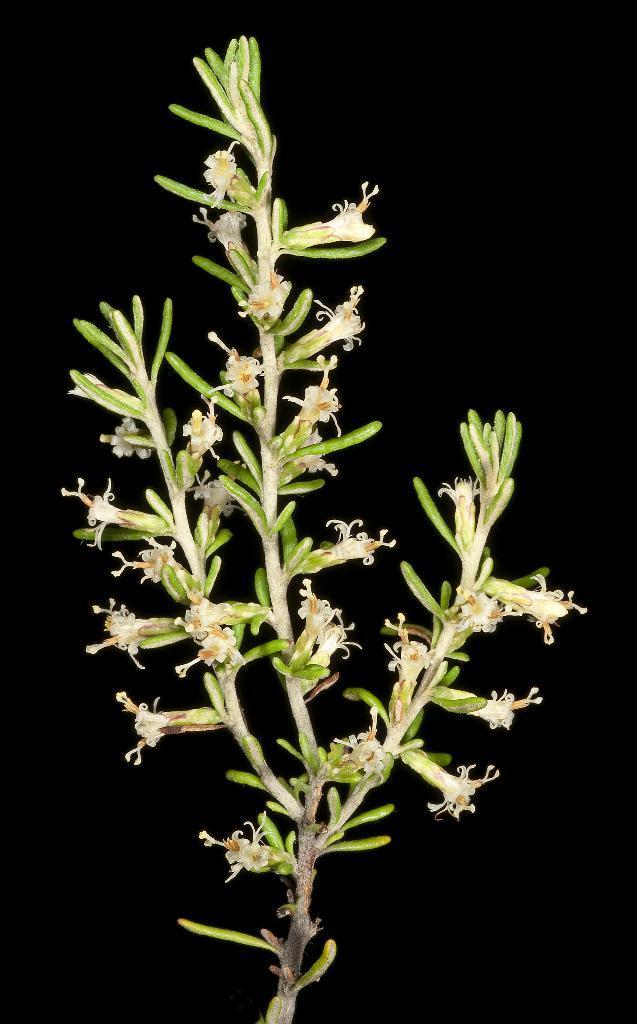Describe this image in one or two sentences. In this image we can see a plant and flowers. There is a dark background. 